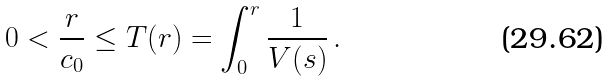<formula> <loc_0><loc_0><loc_500><loc_500>0 < \frac { r } { c _ { 0 } } \leq T ( r ) = \int _ { 0 } ^ { r } \frac { 1 } { V ( s ) } \, .</formula> 